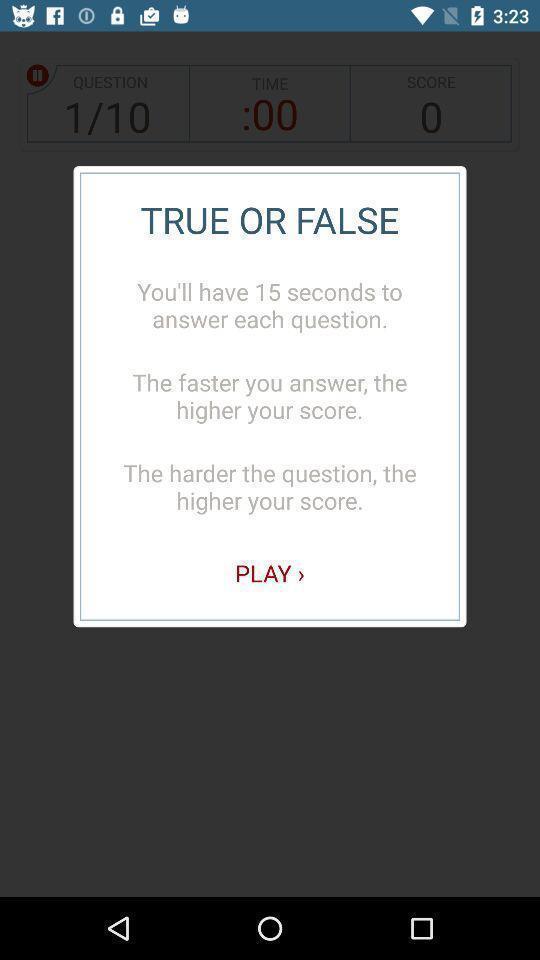Give me a summary of this screen capture. Popup displaying information about a dictionary application. 